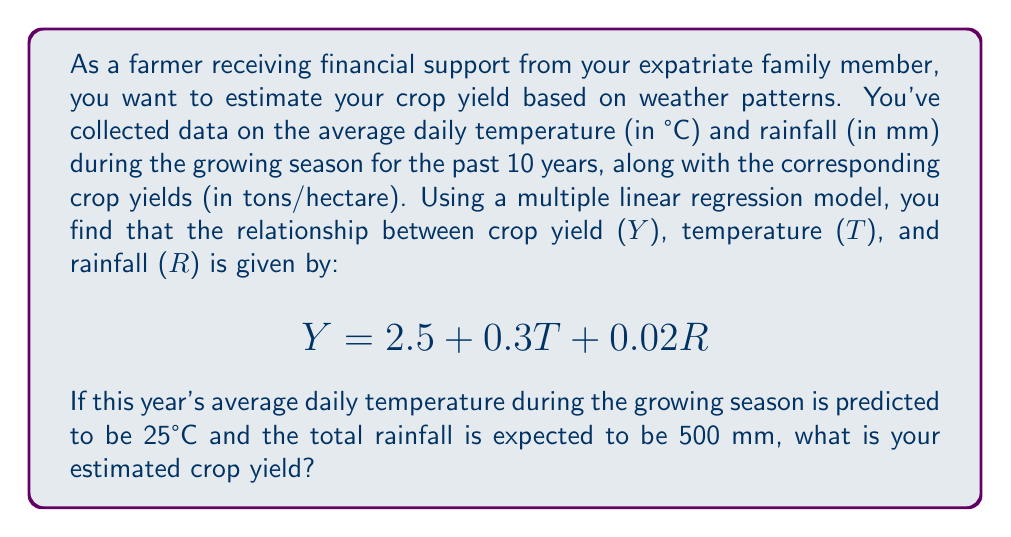Solve this math problem. To estimate the crop yield using the given multiple linear regression model, we need to follow these steps:

1. Identify the equation:
   $$Y = 2.5 + 0.3T + 0.02R$$
   Where:
   $Y$ = Estimated crop yield (tons/hectare)
   $T$ = Average daily temperature (°C)
   $R$ = Total rainfall (mm)

2. Input the given values:
   $T = 25°C$
   $R = 500 mm$

3. Substitute these values into the equation:
   $$Y = 2.5 + 0.3(25) + 0.02(500)$$

4. Calculate the result:
   $$Y = 2.5 + 7.5 + 10$$
   $$Y = 20$$

Therefore, the estimated crop yield based on the given weather patterns is 20 tons/hectare.
Answer: 20 tons/hectare 